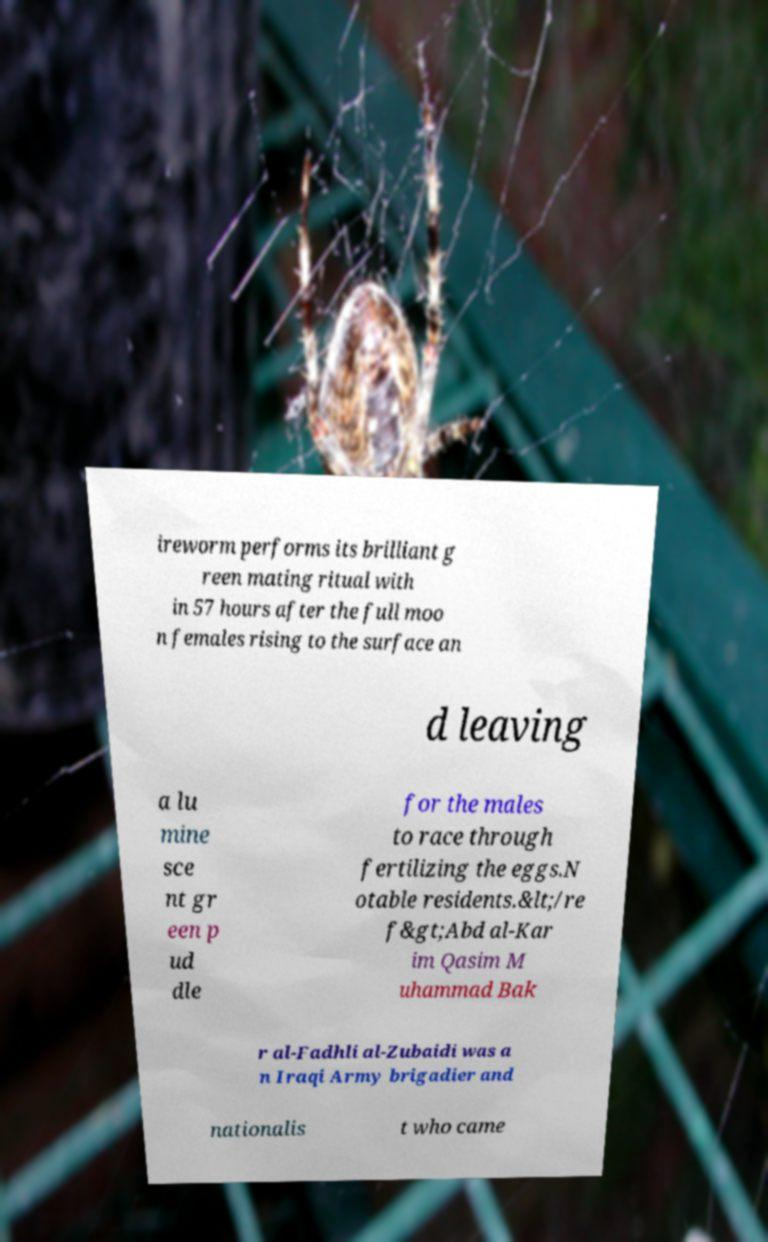Can you accurately transcribe the text from the provided image for me? ireworm performs its brilliant g reen mating ritual with in 57 hours after the full moo n females rising to the surface an d leaving a lu mine sce nt gr een p ud dle for the males to race through fertilizing the eggs.N otable residents.&lt;/re f&gt;Abd al-Kar im Qasim M uhammad Bak r al-Fadhli al-Zubaidi was a n Iraqi Army brigadier and nationalis t who came 